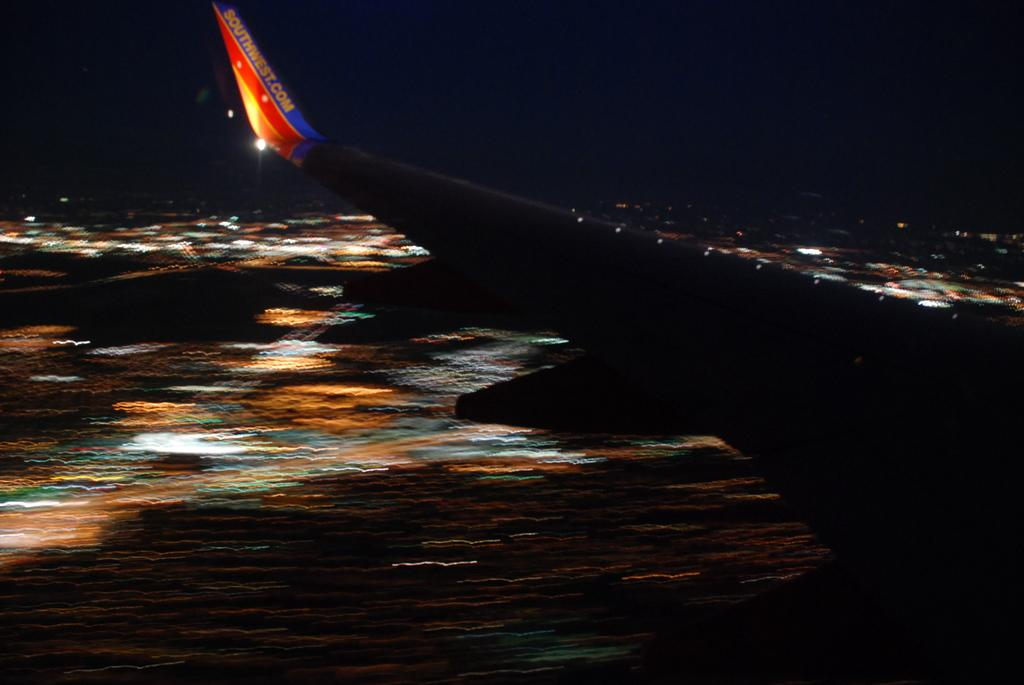<image>
Relay a brief, clear account of the picture shown. The wing of a Southwest airplane is visible agains a blurry nighttime landscape. 